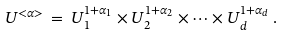<formula> <loc_0><loc_0><loc_500><loc_500>U ^ { < \alpha > } \, = \, U _ { 1 } ^ { 1 + \alpha _ { 1 } } \times U _ { 2 } ^ { 1 + \alpha _ { 2 } } \times \cdots \times U _ { d } ^ { 1 + \alpha _ { d } } \, .</formula> 